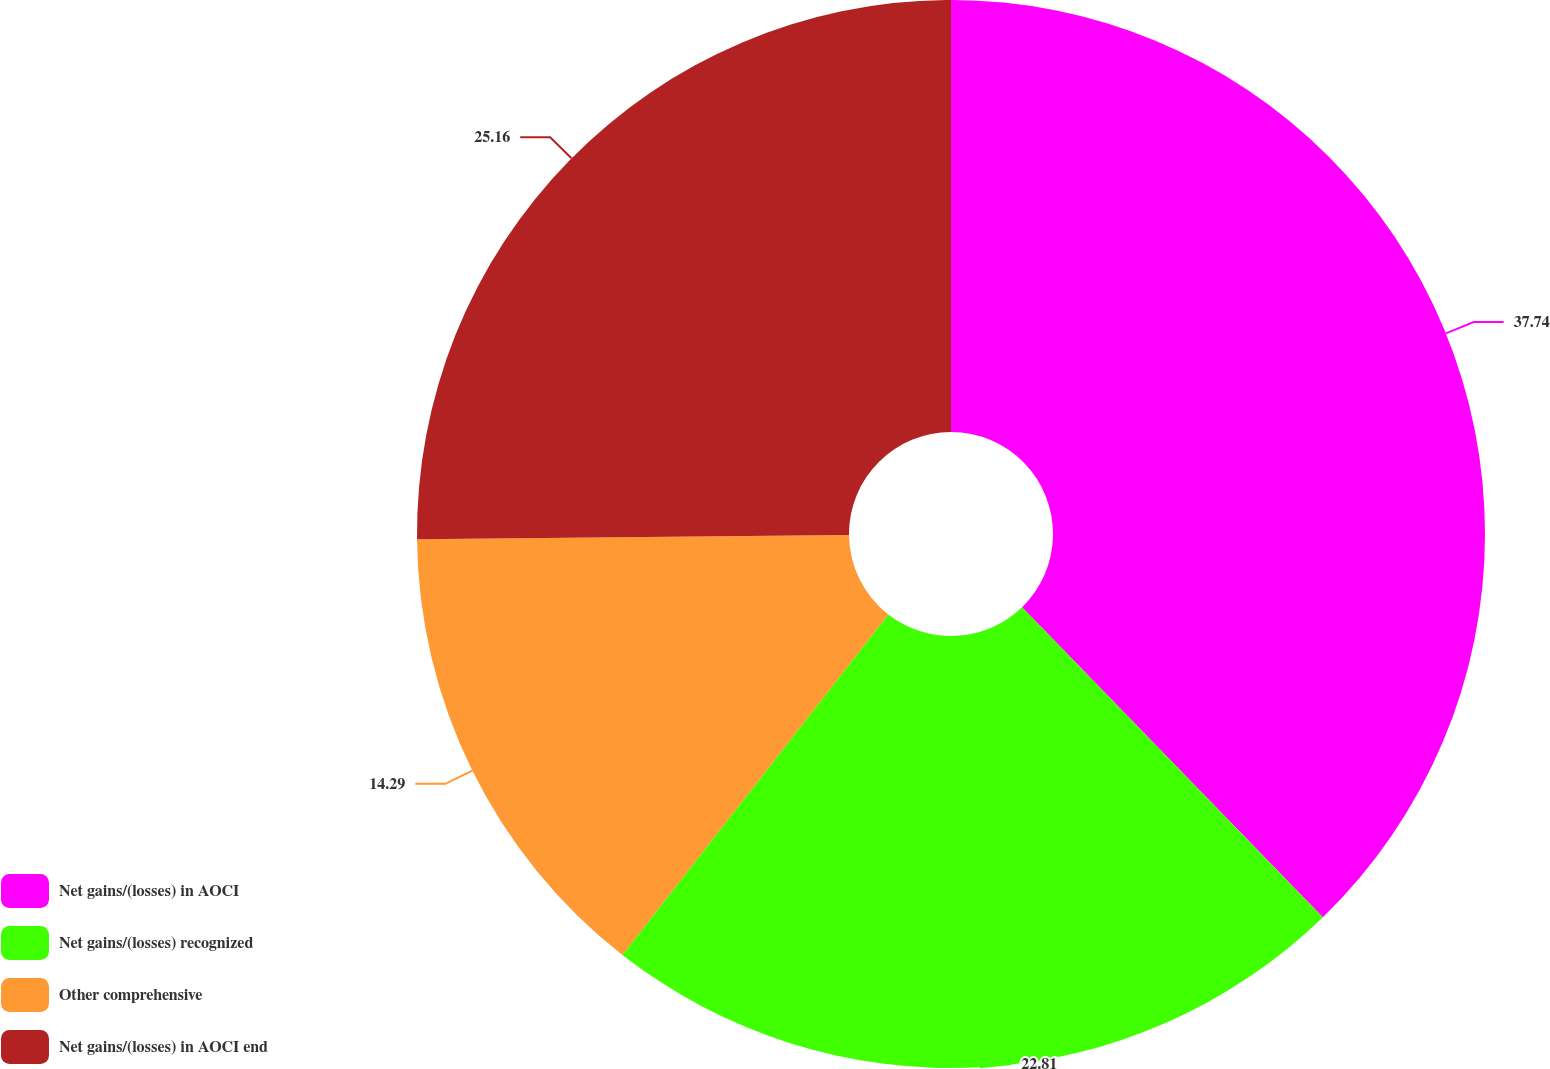Convert chart. <chart><loc_0><loc_0><loc_500><loc_500><pie_chart><fcel>Net gains/(losses) in AOCI<fcel>Net gains/(losses) recognized<fcel>Other comprehensive<fcel>Net gains/(losses) in AOCI end<nl><fcel>37.74%<fcel>22.81%<fcel>14.29%<fcel>25.16%<nl></chart> 